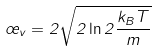<formula> <loc_0><loc_0><loc_500><loc_500>\sigma _ { v } = 2 \sqrt { 2 \ln 2 \frac { k _ { B } T } { m } }</formula> 